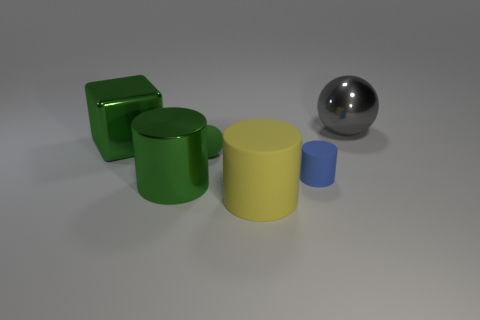There is a sphere that is in front of the big metallic ball; is its size the same as the cylinder that is to the right of the big yellow thing?
Offer a terse response. Yes. What size is the cube that is the same material as the gray thing?
Keep it short and to the point. Large. How many big metallic objects are behind the green shiny block and on the left side of the tiny blue thing?
Ensure brevity in your answer.  0. How many things are either tiny blue matte cylinders or large green objects that are behind the green rubber sphere?
Keep it short and to the point. 2. There is a tiny rubber object that is the same color as the metal cylinder; what shape is it?
Provide a short and direct response. Sphere. There is a cylinder to the left of the matte sphere; what color is it?
Give a very brief answer. Green. What number of objects are green things that are in front of the large metallic cube or large matte objects?
Give a very brief answer. 3. There is a ball that is the same size as the yellow cylinder; what color is it?
Make the answer very short. Gray. Are there more green shiny cylinders behind the large yellow thing than small brown objects?
Make the answer very short. Yes. There is a big thing that is behind the blue matte object and to the right of the big green metallic block; what material is it?
Your answer should be very brief. Metal. 